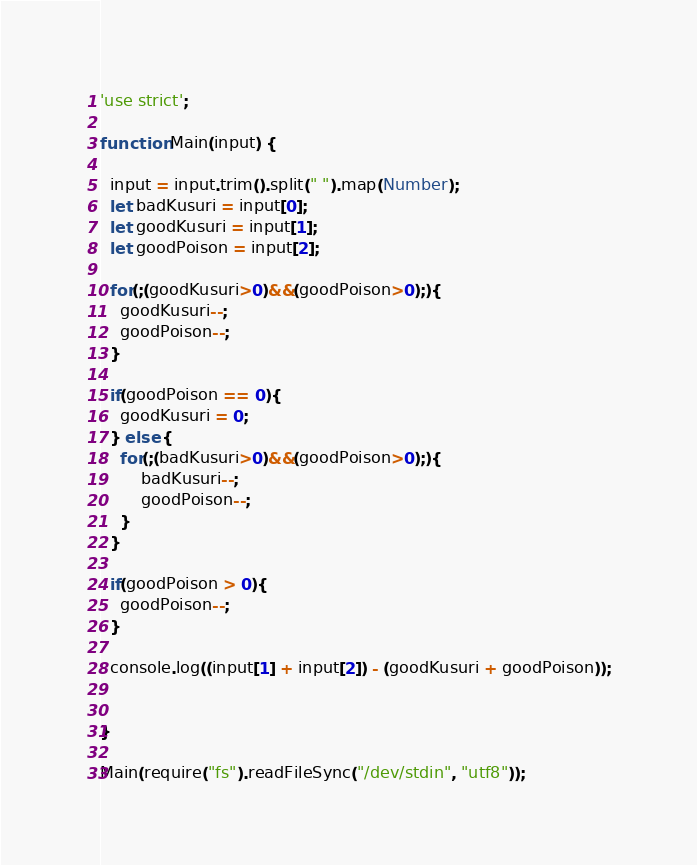<code> <loc_0><loc_0><loc_500><loc_500><_JavaScript_>'use strict';

function Main(input) {

  input = input.trim().split(" ").map(Number);
  let badKusuri = input[0];
  let goodKusuri = input[1];
  let goodPoison = input[2];
  
  for(;(goodKusuri>0)&&(goodPoison>0);){
  	goodKusuri--;
    goodPoison--;
  }
  
  if(goodPoison == 0){
  	goodKusuri = 0;
  } else {
  	for(;(badKusuri>0)&&(goodPoison>0);){
  		badKusuri--;
      	goodPoison--;
  	}
  }
  
  if(goodPoison > 0){
  	goodPoison--;
  }
  
  console.log((input[1] + input[2]) - (goodKusuri + goodPoison));
  
  
}

Main(require("fs").readFileSync("/dev/stdin", "utf8"));</code> 